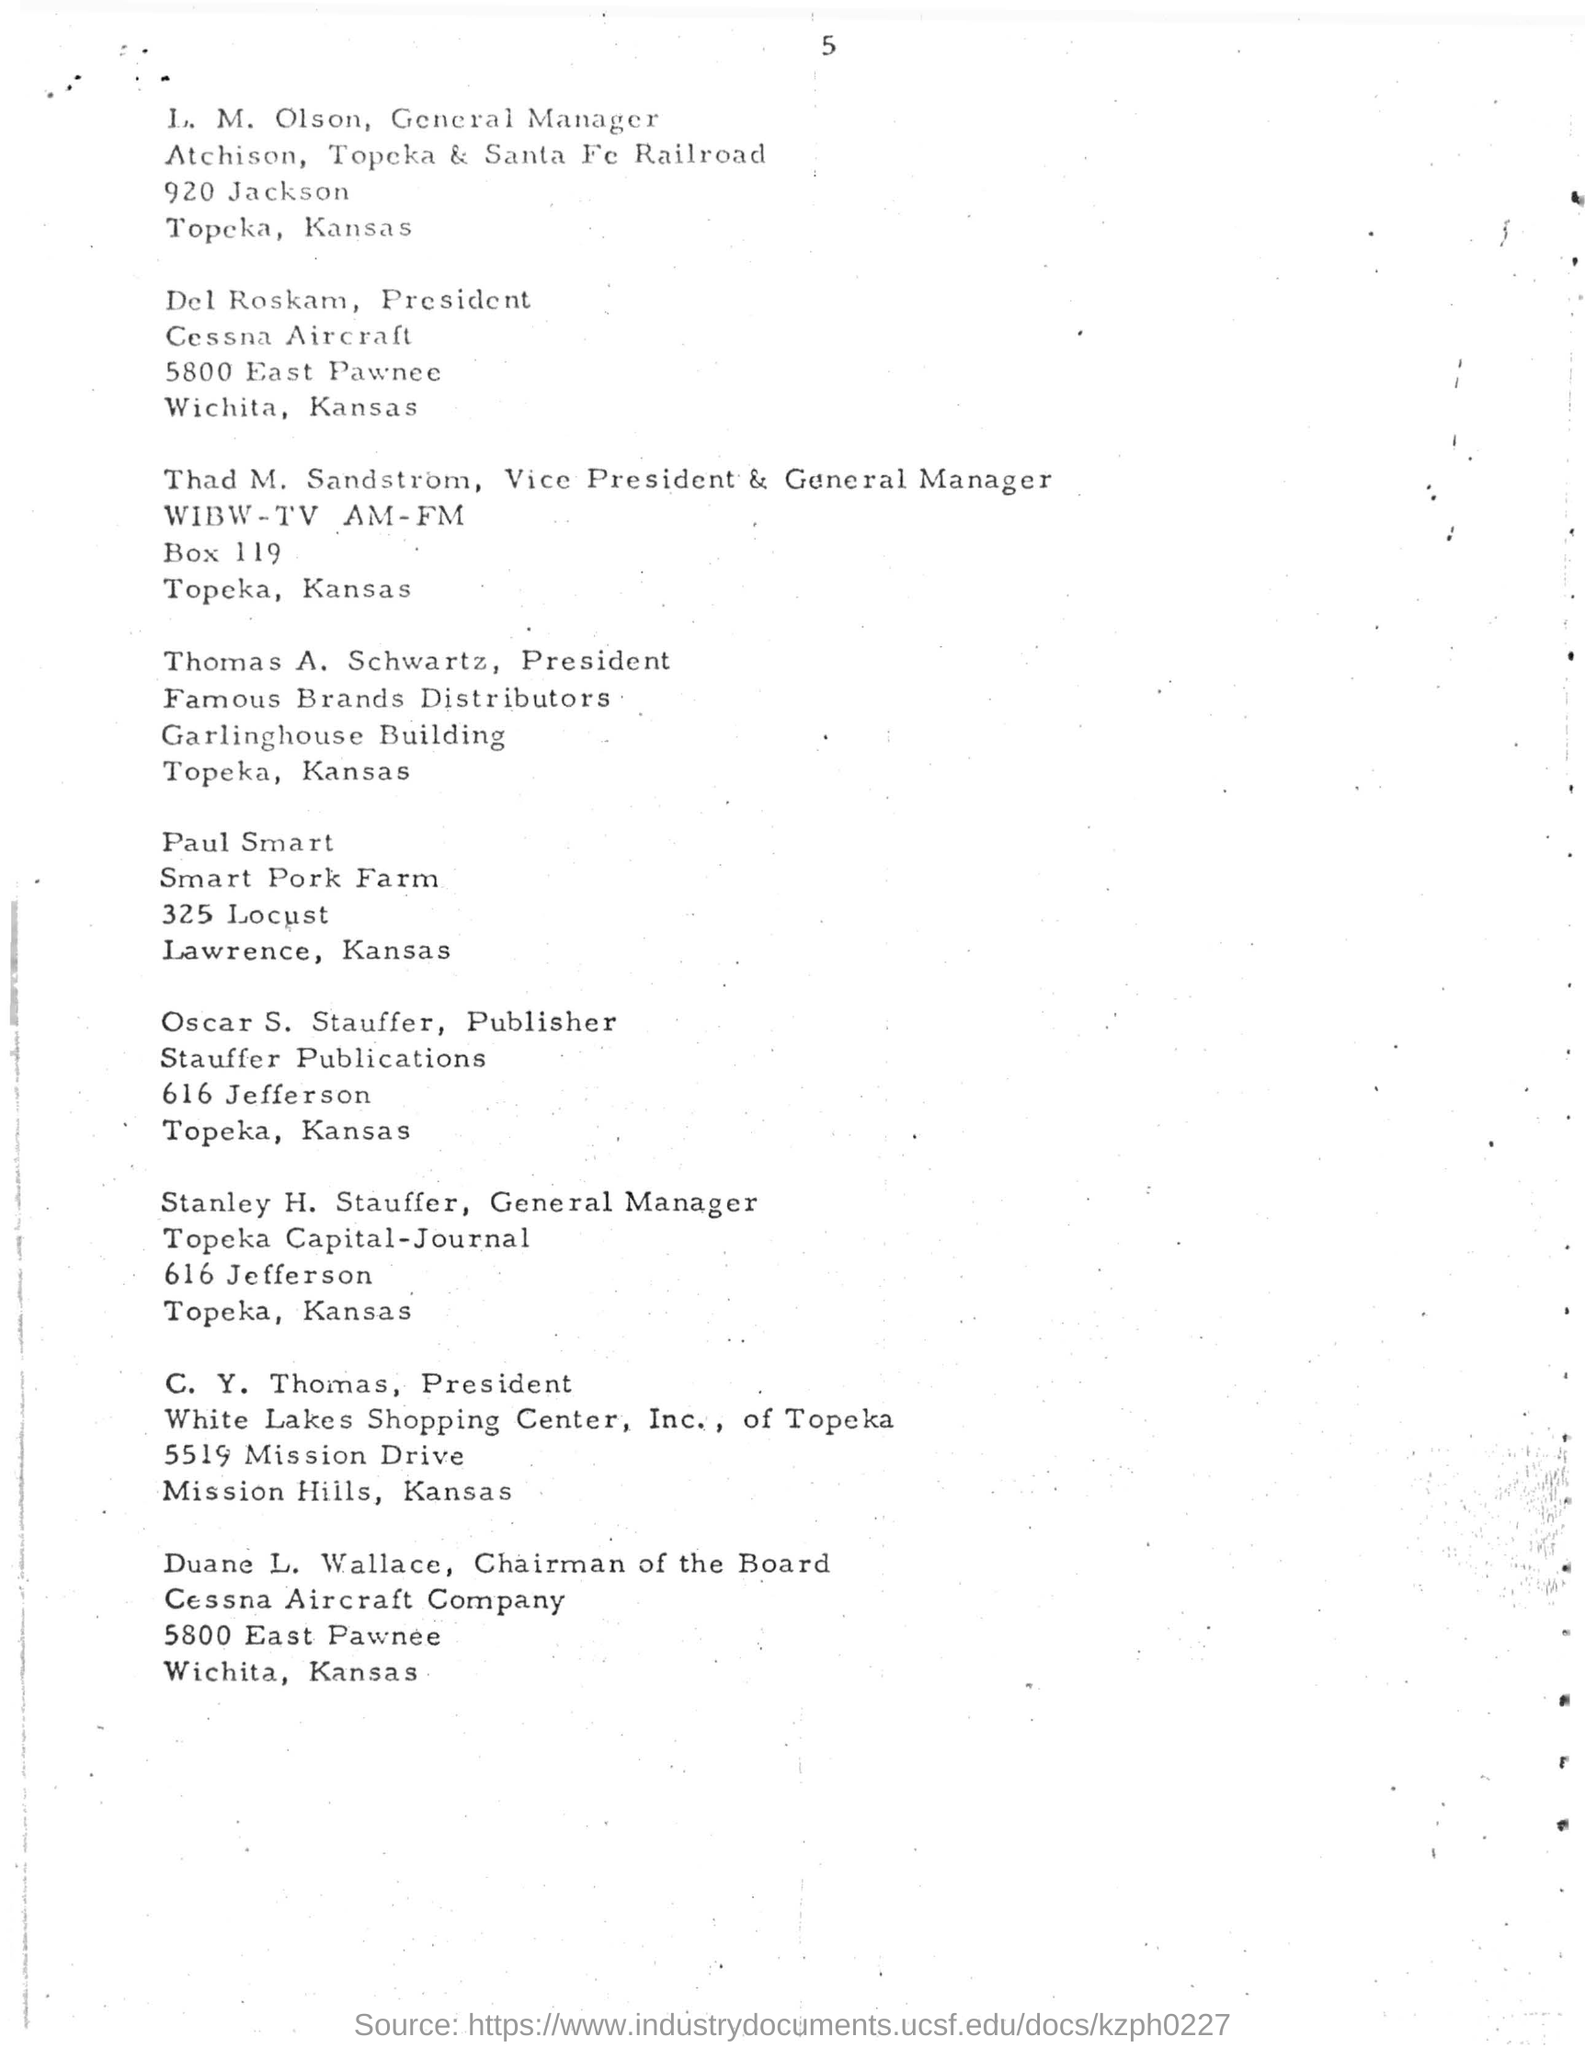Specify some key components in this picture. The general manager of Topeka Capital-Journal is named Stanley H. Stauffer. The president of White Lakes Shopping Center, Inc. of Topeka is C. Y. Thomas. The president of Cessna Aircraft is Del Roskam. The publisher named is Oscar S. Stauffer. Thomas A. Schwartz is the president of Famous Brands Distributors. 